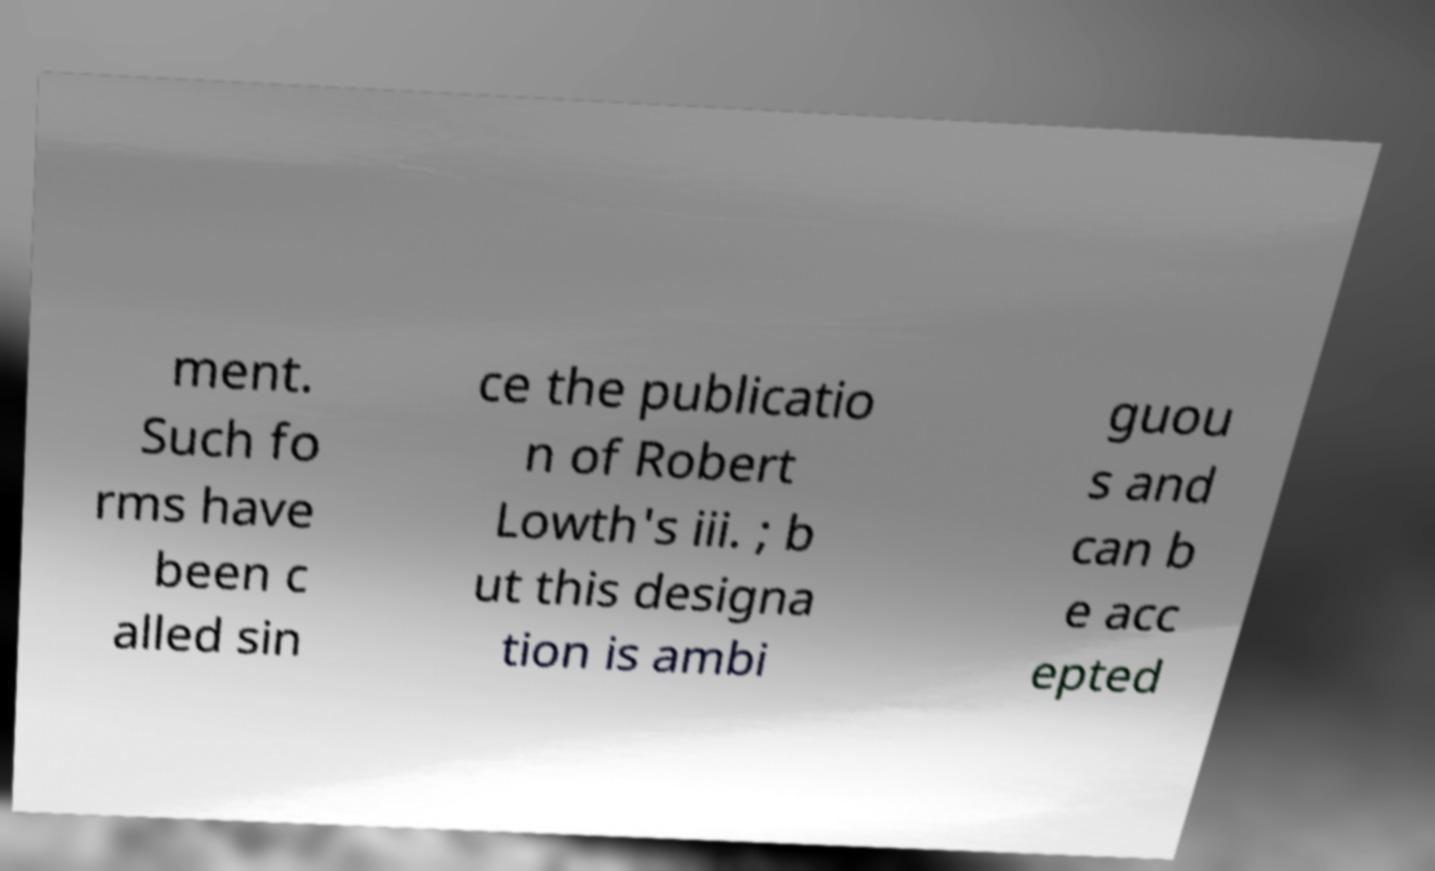Could you extract and type out the text from this image? ment. Such fo rms have been c alled sin ce the publicatio n of Robert Lowth's iii. ; b ut this designa tion is ambi guou s and can b e acc epted 